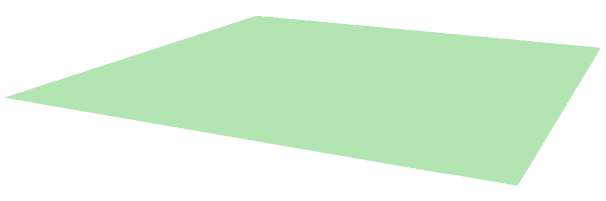A pyramidal rock formation in a desert ecosystem has a square base with sides measuring 4 meters and a height of 3 meters. If the density of succulent plant species on the surface of the rock formation is proportional to its surface area, with 1 species per 5 square meters, how many succulent species would you expect to find on this formation? To solve this problem, we need to follow these steps:

1. Calculate the surface area of the pyramid:
   a. Find the area of the square base
   b. Find the area of a triangular face
   c. Calculate the total surface area

2. Determine the number of succulent species based on the surface area

Step 1a: Area of the square base
$$A_{base} = 4m \times 4m = 16m^2$$

Step 1b: Area of a triangular face
First, we need to find the slant height using the Pythagorean theorem:
$$s^2 = (\frac{4}{2})^2 + 3^2$$
$$s^2 = 2^2 + 3^2 = 4 + 9 = 13$$
$$s = \sqrt{13} \approx 3.61m$$

Now we can calculate the area of one triangular face:
$$A_{face} = \frac{1}{2} \times 4m \times 3.61m = 7.22m^2$$

Step 1c: Total surface area
$$A_{total} = A_{base} + 4 \times A_{face}$$
$$A_{total} = 16m^2 + 4 \times 7.22m^2 = 16 + 28.88 = 44.88m^2$$

Step 2: Number of succulent species
Given that there is 1 species per 5 square meters, we can calculate the number of species:
$$\text{Number of species} = \frac{A_{total}}{5m^2/species} = \frac{44.88m^2}{5m^2/species} \approx 8.98$$

Since we can't have a fractional number of species, we round to the nearest whole number.
Answer: 9 succulent species 